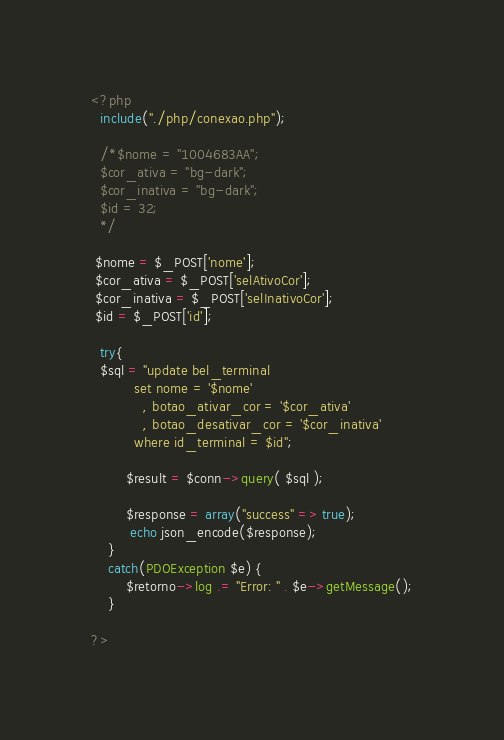Convert code to text. <code><loc_0><loc_0><loc_500><loc_500><_PHP_><?php
  include("./php/conexao.php");

  /*$nome = "1004683AA";
  $cor_ativa = "bg-dark";
  $cor_inativa = "bg-dark";
  $id = 32;
  */

 $nome = $_POST['nome'];
 $cor_ativa = $_POST['selAtivoCor'];
 $cor_inativa = $_POST['selInativoCor'];
 $id = $_POST['id'];

  try{
  $sql = "update bel_terminal
          set nome = '$nome'
            , botao_ativar_cor = '$cor_ativa'
            , botao_desativar_cor = '$cor_inativa'
          where id_terminal = $id";

		$result = $conn->query( $sql );

        $response = array("success" => true);
         echo json_encode($response);
	}
	catch(PDOException $e) {
	    $retorno->log .= "Error: " . $e->getMessage();
	}

?>
</code> 